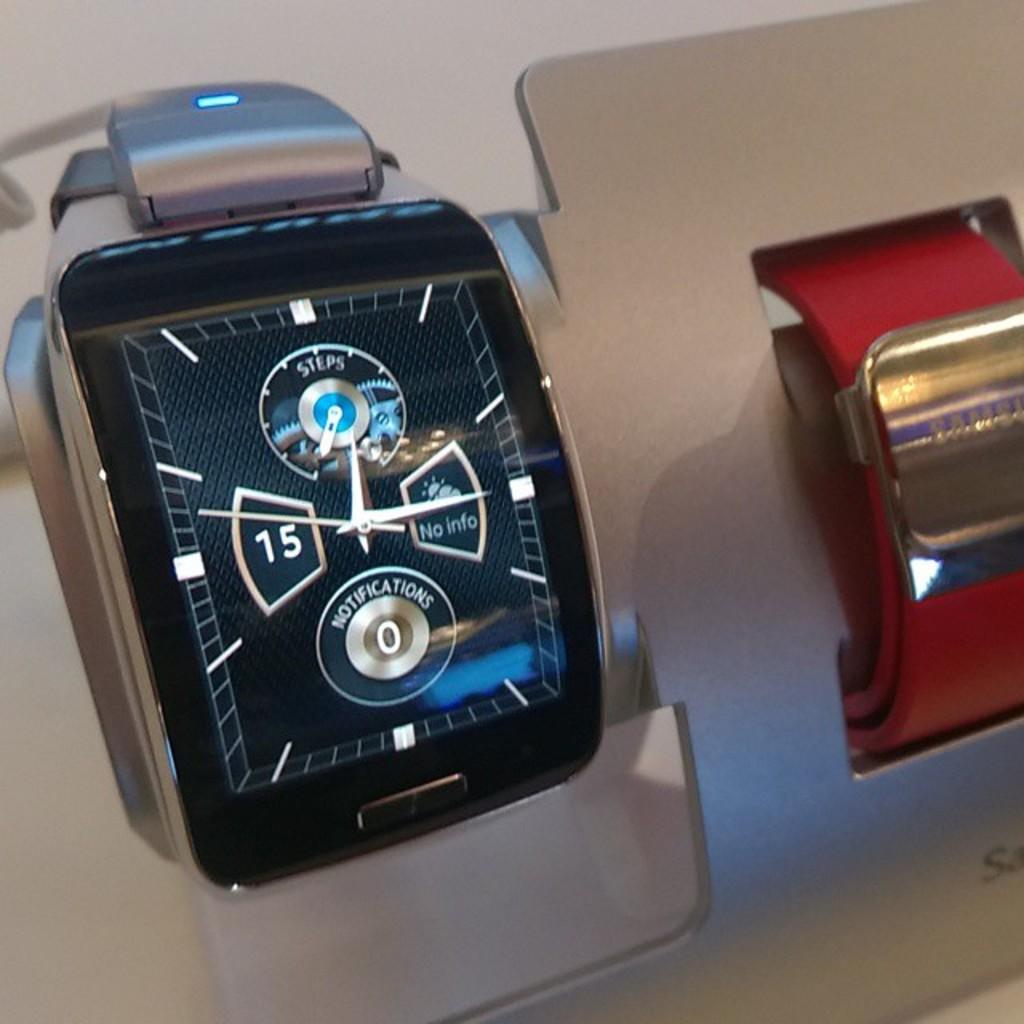What is the number on the watch?
Your answer should be compact. 15. What time is shown on the watch?
Provide a succinct answer. 12:15. 